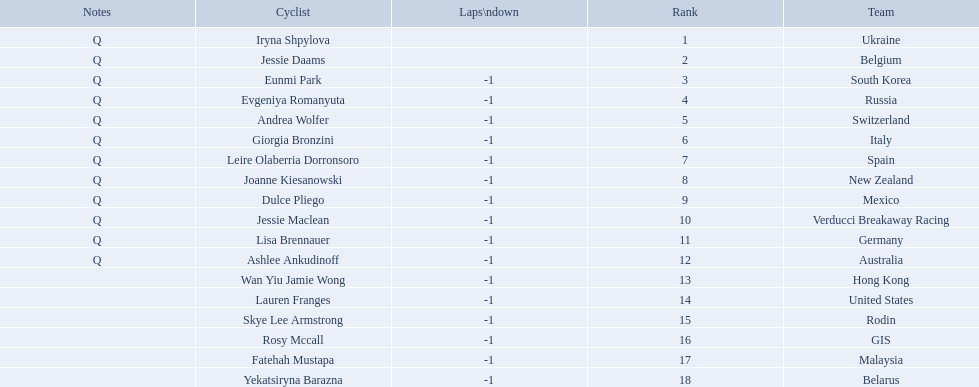Who are all the cyclists? Iryna Shpylova, Jessie Daams, Eunmi Park, Evgeniya Romanyuta, Andrea Wolfer, Giorgia Bronzini, Leire Olaberria Dorronsoro, Joanne Kiesanowski, Dulce Pliego, Jessie Maclean, Lisa Brennauer, Ashlee Ankudinoff, Wan Yiu Jamie Wong, Lauren Franges, Skye Lee Armstrong, Rosy Mccall, Fatehah Mustapa, Yekatsiryna Barazna. What were their ranks? 1, 2, 3, 4, 5, 6, 7, 8, 9, 10, 11, 12, 13, 14, 15, 16, 17, 18. Who was ranked highest? Iryna Shpylova. 